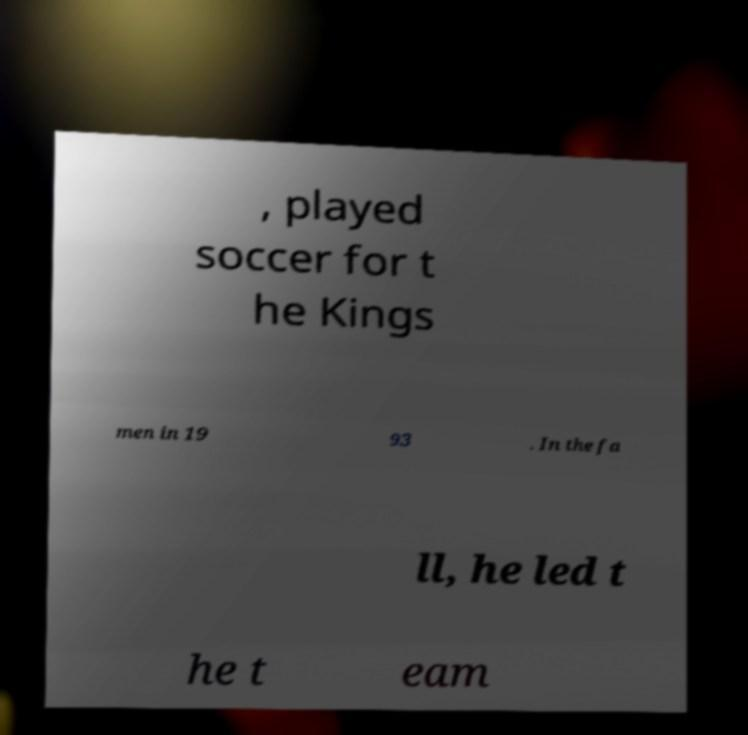For documentation purposes, I need the text within this image transcribed. Could you provide that? , played soccer for t he Kings men in 19 93 . In the fa ll, he led t he t eam 